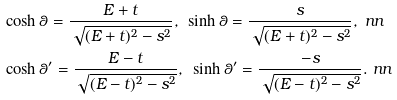Convert formula to latex. <formula><loc_0><loc_0><loc_500><loc_500>& \cosh \theta = \frac { E + t } { \sqrt { ( E + t ) ^ { 2 } - s ^ { 2 } } } , \, \ \sinh \theta = \frac { s } { \sqrt { ( E + t ) ^ { 2 } - s ^ { 2 } } } , \ n n \\ & \cosh \theta ^ { \prime } = \frac { E - t } { \sqrt { ( E - t ) ^ { 2 } - s ^ { 2 } } } , \, \ \sinh \theta ^ { \prime } = \frac { - s } { \sqrt { ( E - t ) ^ { 2 } - s ^ { 2 } } } . \ n n</formula> 